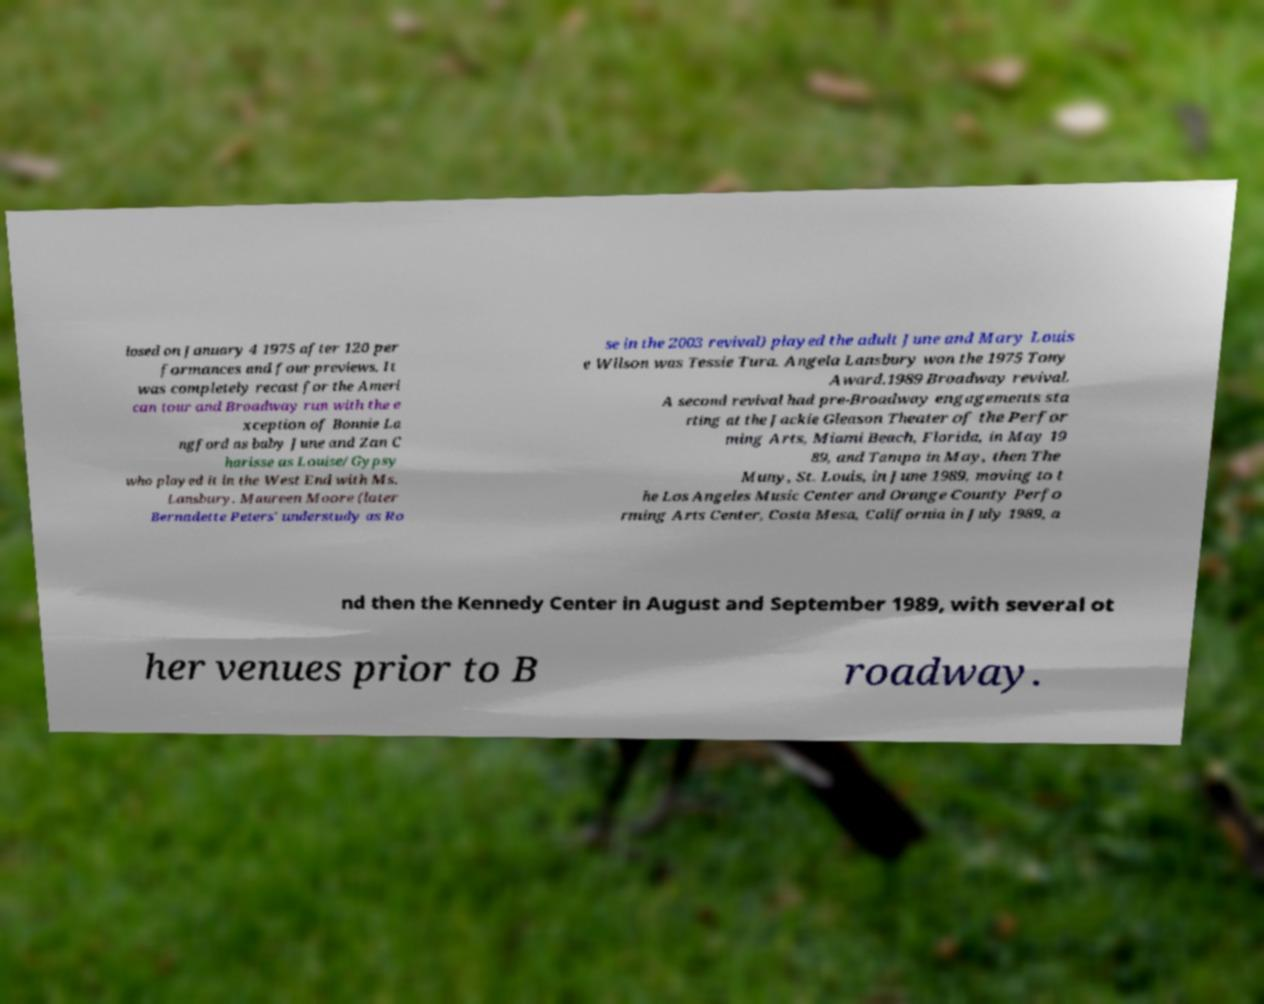Can you read and provide the text displayed in the image?This photo seems to have some interesting text. Can you extract and type it out for me? losed on January 4 1975 after 120 per formances and four previews. It was completely recast for the Ameri can tour and Broadway run with the e xception of Bonnie La ngford as baby June and Zan C harisse as Louise/Gypsy who played it in the West End with Ms. Lansbury. Maureen Moore (later Bernadette Peters' understudy as Ro se in the 2003 revival) played the adult June and Mary Louis e Wilson was Tessie Tura. Angela Lansbury won the 1975 Tony Award.1989 Broadway revival. A second revival had pre-Broadway engagements sta rting at the Jackie Gleason Theater of the Perfor ming Arts, Miami Beach, Florida, in May 19 89, and Tampa in May, then The Muny, St. Louis, in June 1989, moving to t he Los Angeles Music Center and Orange County Perfo rming Arts Center, Costa Mesa, California in July 1989, a nd then the Kennedy Center in August and September 1989, with several ot her venues prior to B roadway. 